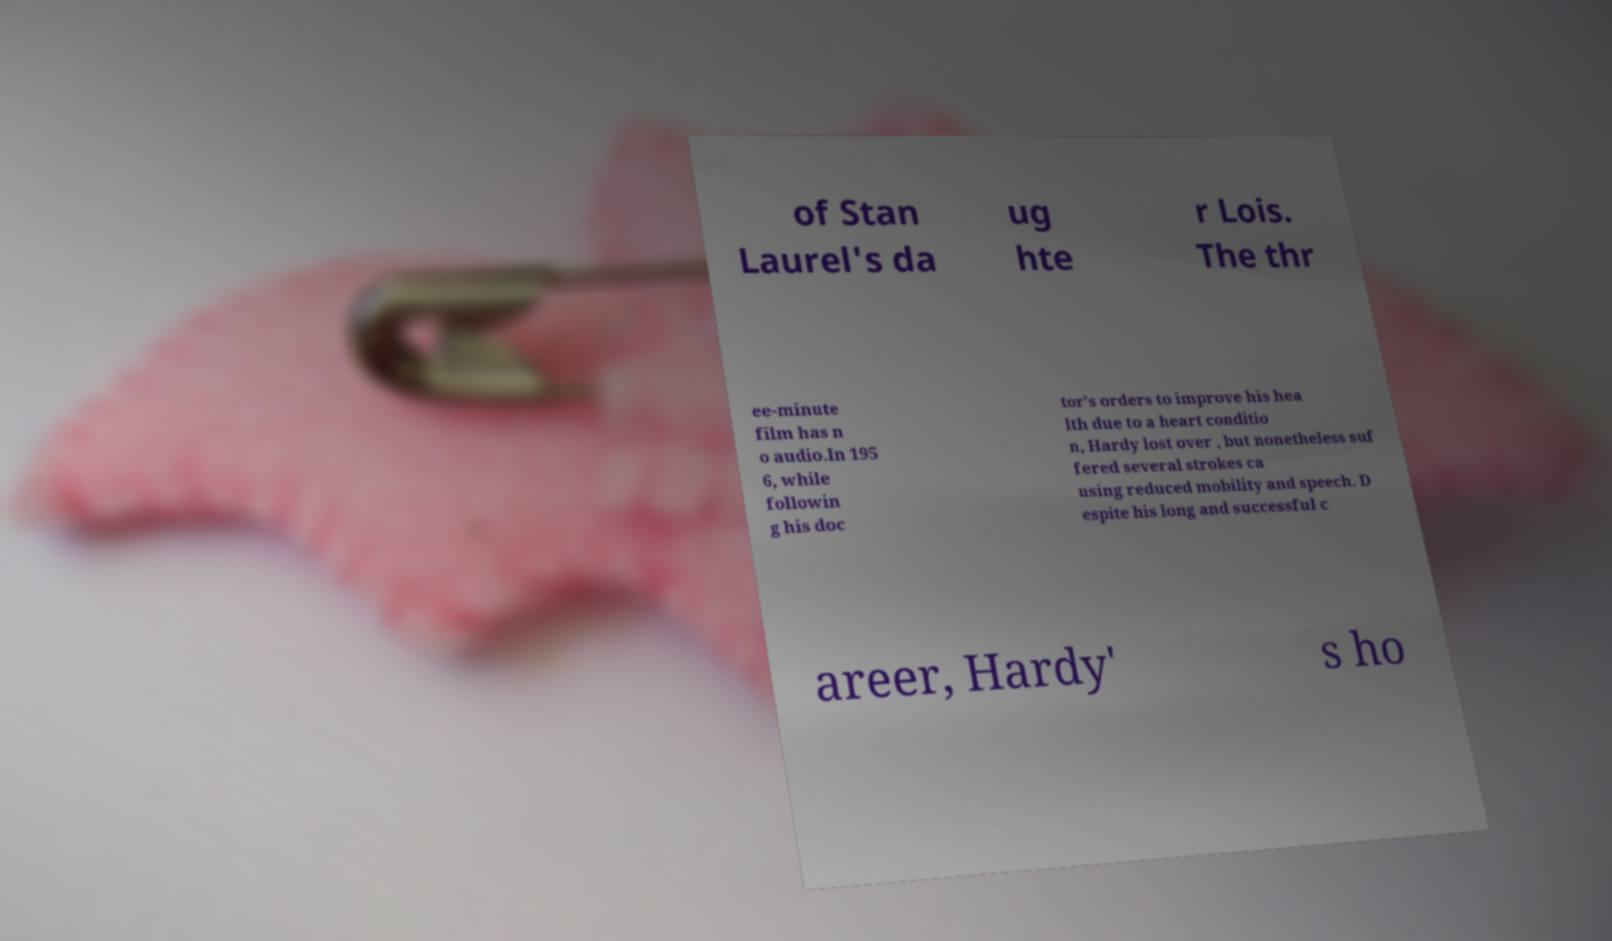There's text embedded in this image that I need extracted. Can you transcribe it verbatim? of Stan Laurel's da ug hte r Lois. The thr ee-minute film has n o audio.In 195 6, while followin g his doc tor's orders to improve his hea lth due to a heart conditio n, Hardy lost over , but nonetheless suf fered several strokes ca using reduced mobility and speech. D espite his long and successful c areer, Hardy' s ho 